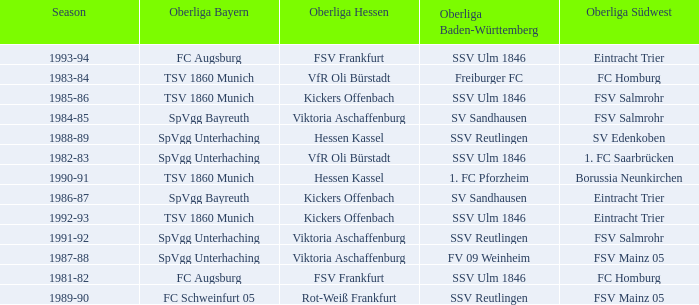Which Oberliga Bayern has a Season of 1981-82? FC Augsburg. 